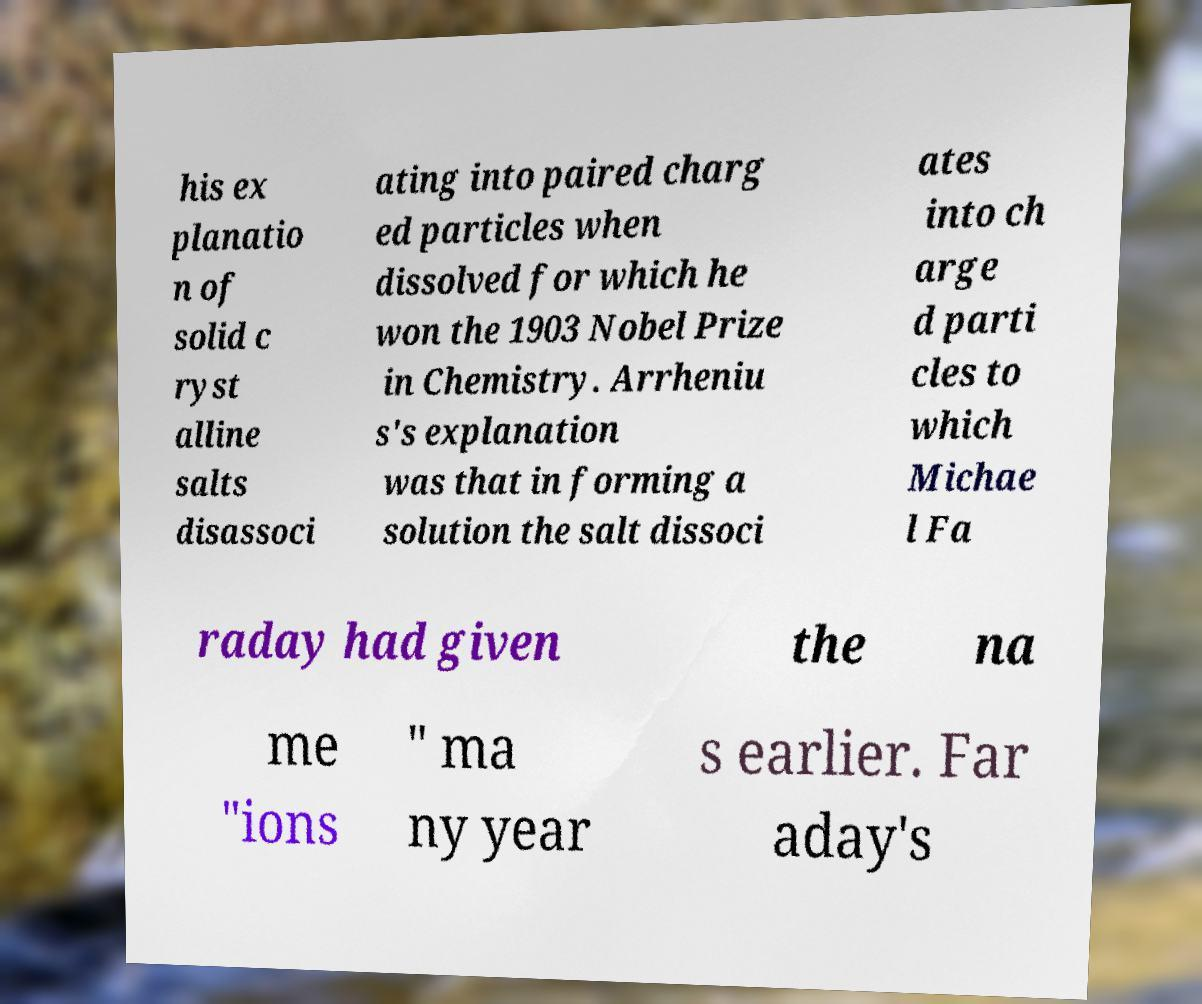Please read and relay the text visible in this image. What does it say? his ex planatio n of solid c ryst alline salts disassoci ating into paired charg ed particles when dissolved for which he won the 1903 Nobel Prize in Chemistry. Arrheniu s's explanation was that in forming a solution the salt dissoci ates into ch arge d parti cles to which Michae l Fa raday had given the na me "ions " ma ny year s earlier. Far aday's 